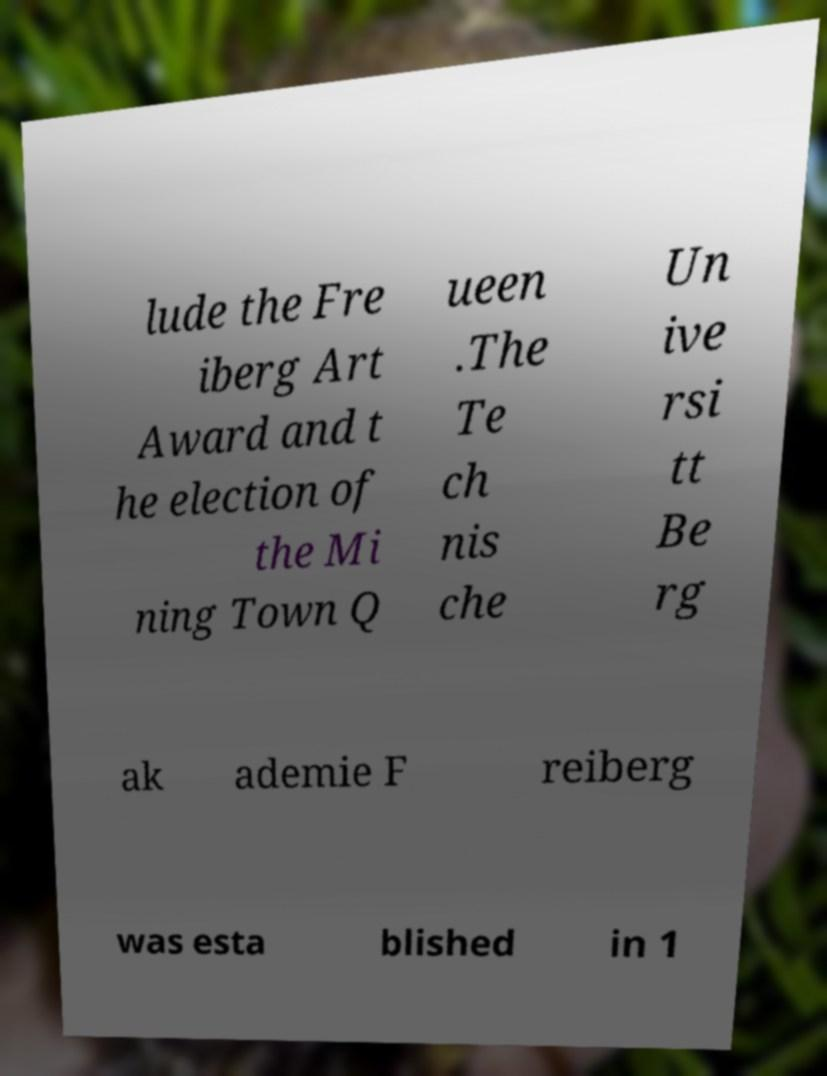There's text embedded in this image that I need extracted. Can you transcribe it verbatim? lude the Fre iberg Art Award and t he election of the Mi ning Town Q ueen .The Te ch nis che Un ive rsi tt Be rg ak ademie F reiberg was esta blished in 1 